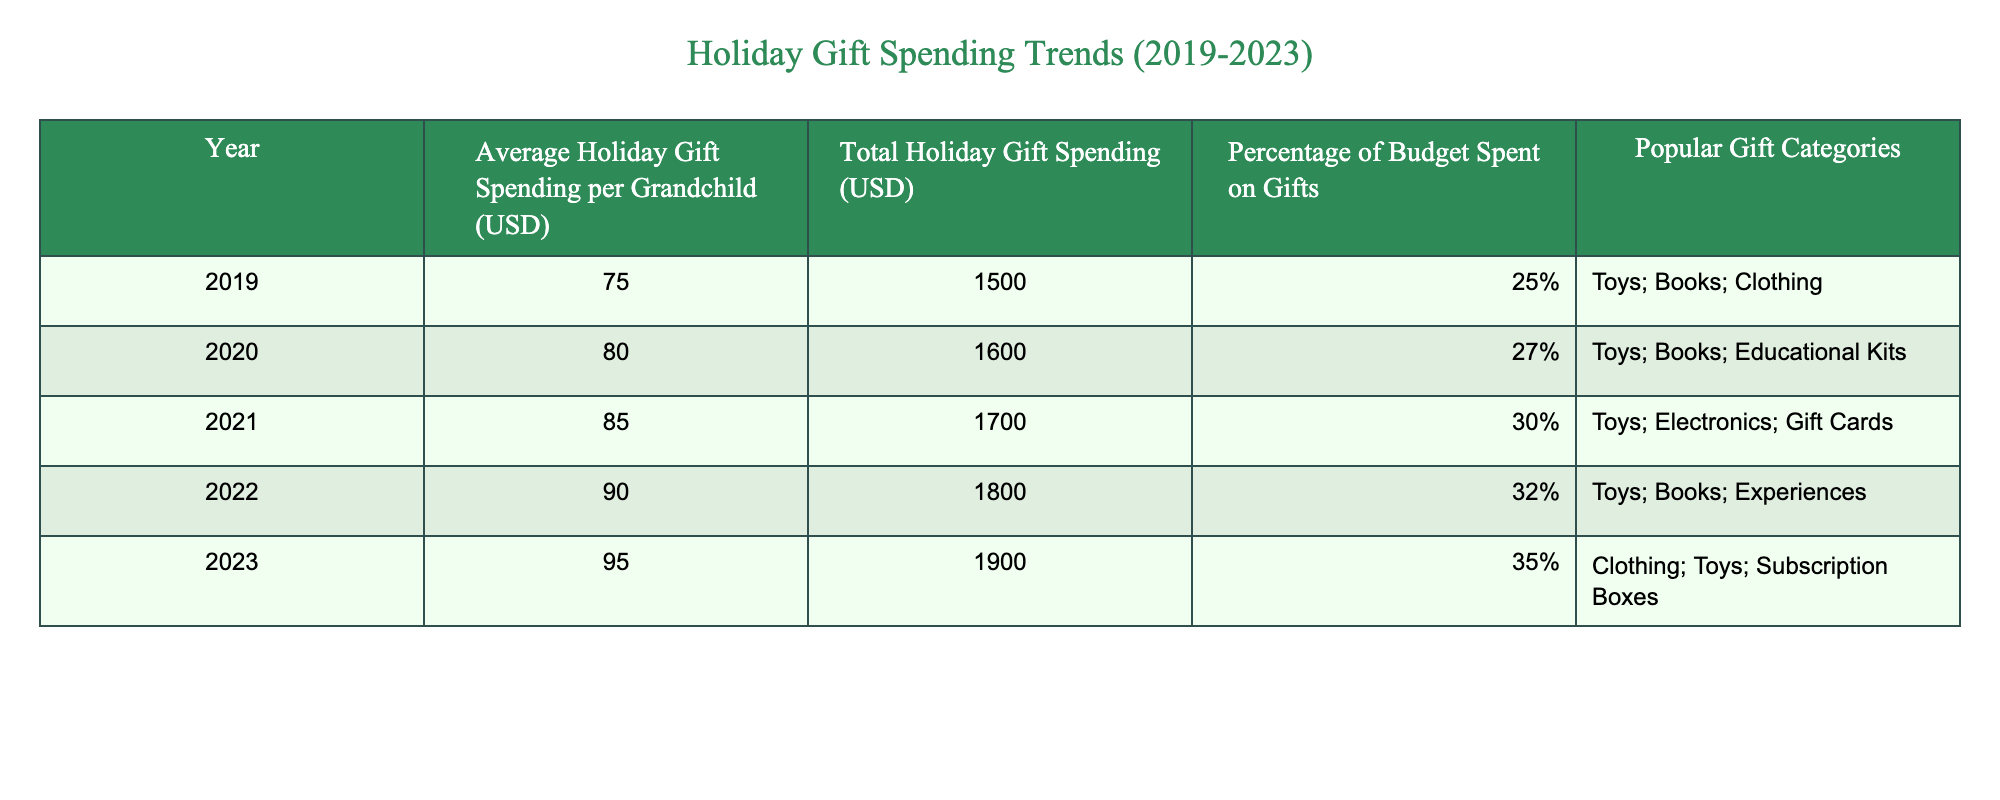What was the average holiday gift spending per grandchild in 2021? The table lists the average holiday gift spending per grandchild for each year. In 2021, the average spending was 85 USD, which is directly stated in the table.
Answer: 85 USD What percentage of the budget was spent on gifts in 2022? According to the table, the percentage of the budget spent on gifts for the year 2022 is clearly indicated as 32%.
Answer: 32% What was the total holiday gift spending in 2020 compared to 2019? By looking at the "Total Holiday Gift Spending" column, the total for 2020 is 1600 USD and for 2019 is 1500 USD. The difference between the two years is 1600 - 1500 = 100 USD, showing that spending increased by 100 USD.
Answer: 100 USD Was there an increase in average holiday gift spending per grandchild from 2019 to 2023? The average spending per grandchild in 2019 was 75 USD, and in 2023 it was 95 USD. Calculating the difference shows an increase of 95 - 75 = 20 USD. Therefore, there was an increase in spending.
Answer: Yes What was the most popular gift category in 2023? The gift category listed for 2023 under "Popular Gift Categories" is Clothing, Toys, and Subscription Boxes. Since this is the only year listed here, we identify these as popular gifts for that year.
Answer: Clothing, Toys, Subscription Boxes How does the percentage of budget spent on gifts change from 2020 to 2023? The percentage in 2020 was 27% and in 2023 it rose to 35%. To find the change, subtract the two percentages: 35% - 27% = 8%. Hence, the percentage increased by 8% over these years.
Answer: 8% What was the total holiday gift spending in 2021? The total holiday gift spending for 2021 is specifically stated in the table as 1700 USD.
Answer: 1700 USD Total average holiday gift spending per grandchild from 2019 to 2023? To find the total average over these years, sum the average spending for each year: (75 + 80 + 85 + 90 + 95) = 425 USD. Then divide by the number of years (5) to find the average: 425 USD / 5 = 85 USD.
Answer: 85 USD What was the increase in total holiday gift spending from 2022 to 2023? The total spending for 2022 was 1800 USD and for 2023 it was 1900 USD. The increase is calculated as 1900 - 1800 = 100 USD.
Answer: 100 USD Was Electronics among the popular gift categories in 2020? Referring to the table, it shows that in 2020, the popular gift categories were Toys, Books, and Educational Kits. Electronics was not mentioned as one of them, so the answer is no.
Answer: No 